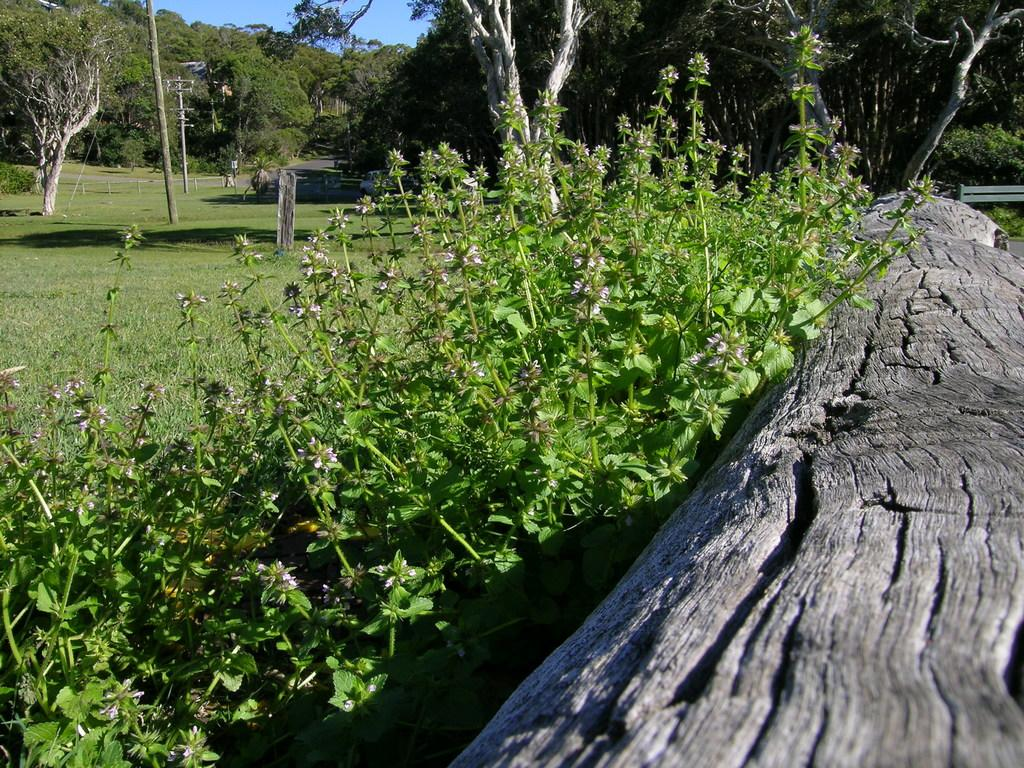What is the main subject in the front of the image? There is a tree trunk in the front of the image. What can be seen behind the tree trunk? There is a garden behind the tree trunk. What is present in the garden? There are trees in the garden. What is visible in the background of the image? There are many trees visible in the background of the image. What type of breakfast is being served on the tree trunk in the image? There is no breakfast present in the image; it features a tree trunk, a garden, and trees. 